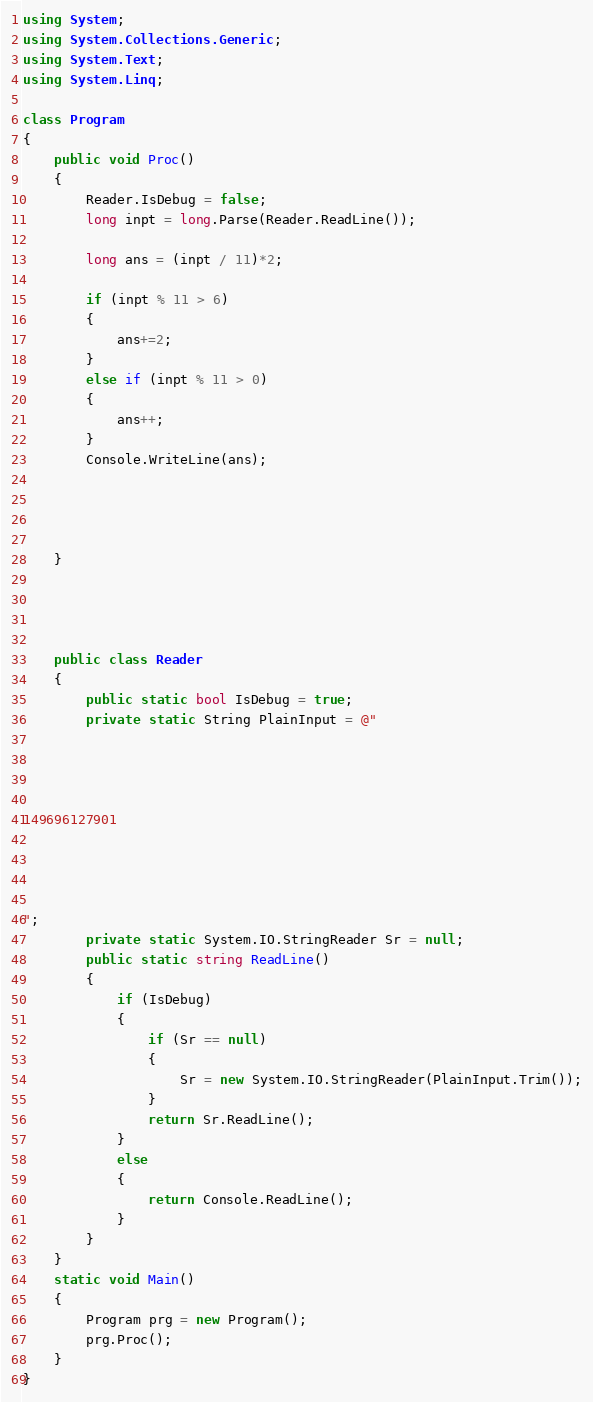<code> <loc_0><loc_0><loc_500><loc_500><_C#_>using System;
using System.Collections.Generic;
using System.Text;
using System.Linq;

class Program
{
    public void Proc()
    {
        Reader.IsDebug = false;
        long inpt = long.Parse(Reader.ReadLine());

        long ans = (inpt / 11)*2;

        if (inpt % 11 > 6)
        {
            ans+=2;
        }
        else if (inpt % 11 > 0)
        {
            ans++;
        }
        Console.WriteLine(ans);




    }




    public class Reader
    {
        public static bool IsDebug = true;
        private static String PlainInput = @"




149696127901




";
        private static System.IO.StringReader Sr = null;
        public static string ReadLine()
        {
            if (IsDebug)
            {
                if (Sr == null)
                {
                    Sr = new System.IO.StringReader(PlainInput.Trim());
                }
                return Sr.ReadLine();
            }
            else
            {
                return Console.ReadLine();
            }
        }
    }
    static void Main()
    {
        Program prg = new Program();
        prg.Proc();
    }
}</code> 